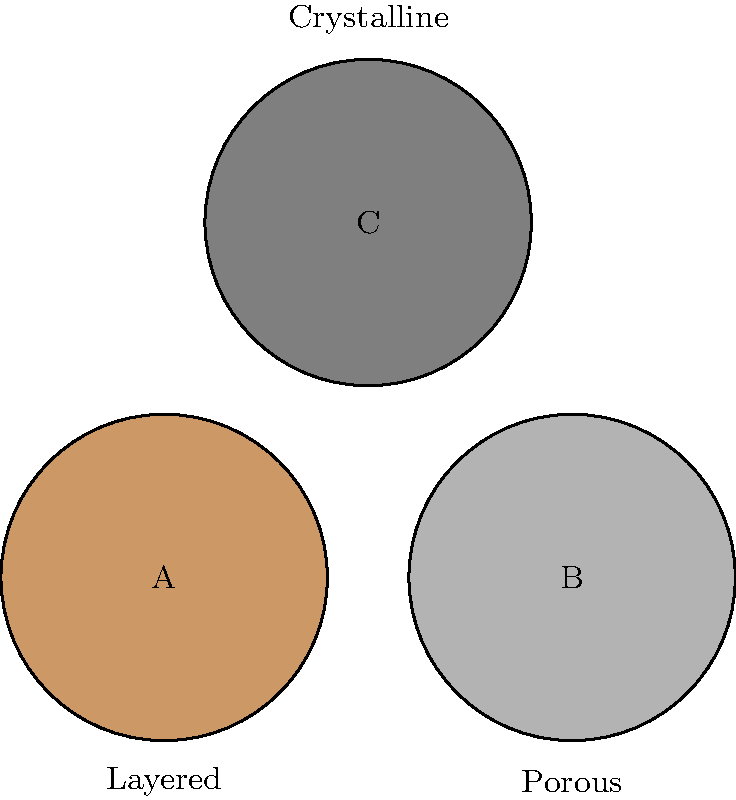As an artist inspired by rock formations, you encounter three distinct rock samples labeled A, B, and C. Based on their visual characteristics shown in the diagram, which rock formation is most likely to be sedimentary? To answer this question, we need to analyze the visual characteristics of each rock sample and compare them to known properties of sedimentary rocks:

1. Rock A: 
   - Appears to have a layered structure
   - Color is a light brownish tone (rgb(0.8,0.6,0.4))
   - Labeled as "Layered"

2. Rock B:
   - Appears to have a porous texture
   - Color is a light gray tone (rgb(0.7,0.7,0.7))
   - Labeled as "Porous"

3. Rock C:
   - Appears to have a crystalline structure
   - Color is a darker gray tone (rgb(0.5,0.5,0.5))
   - Labeled as "Crystalline"

Sedimentary rocks are characterized by:
- Layered structures due to deposition of sediments over time
- Often have visible bedding planes
- Can be porous due to spaces between sediment particles
- Colors can vary widely but often include earth tones

Based on these characteristics, Rock A is the most likely to be sedimentary due to its layered structure and earth-tone color. The layering is a key indicator of sedimentary processes.

Rock B, while porous (which can be a characteristic of some sedimentary rocks), lacks the distinct layering typical of most sedimentary formations.

Rock C's crystalline structure is more indicative of igneous or metamorphic rocks, making it the least likely to be sedimentary.
Answer: Rock A 